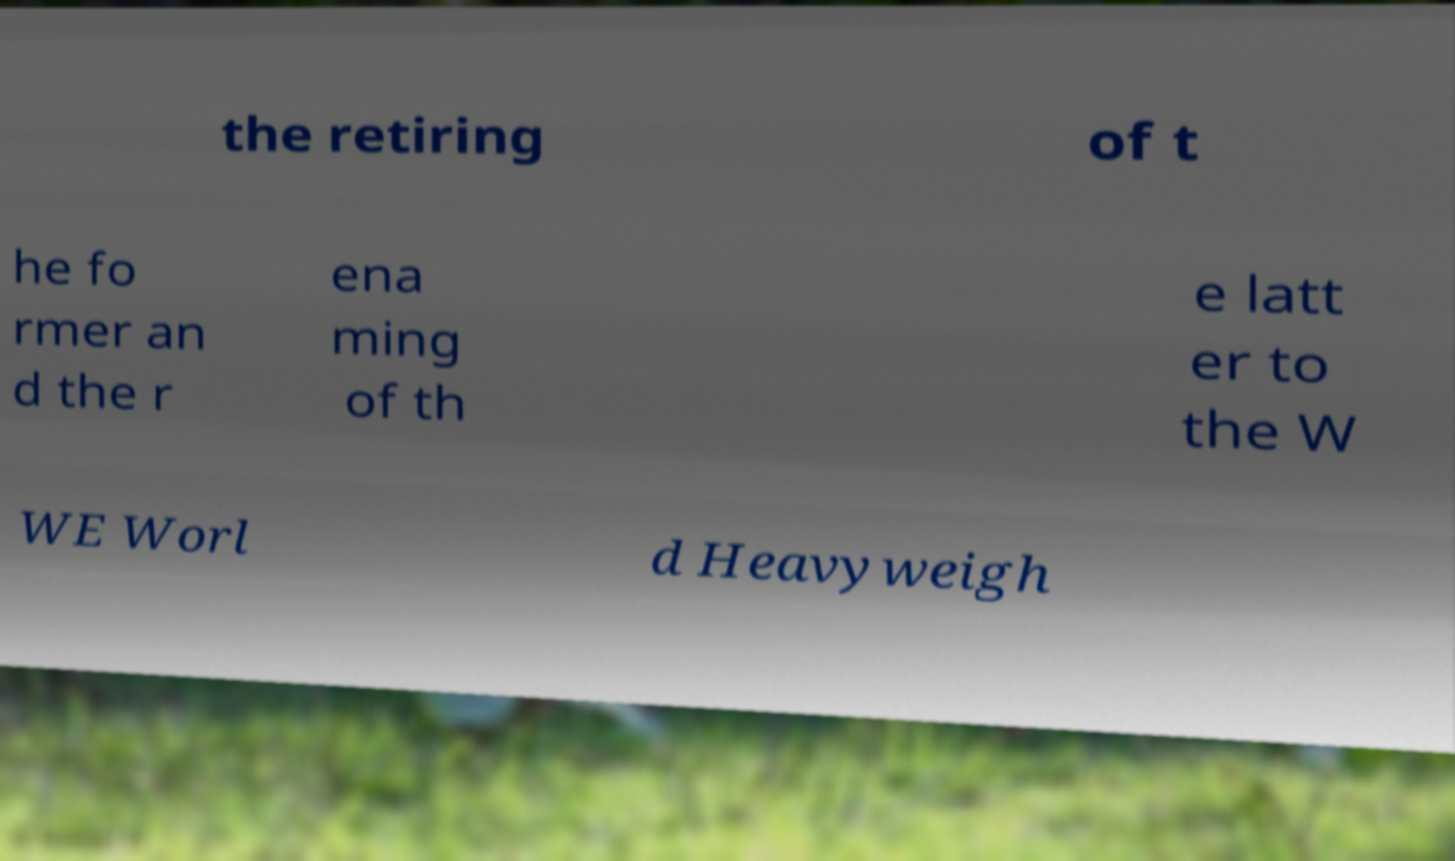What messages or text are displayed in this image? I need them in a readable, typed format. the retiring of t he fo rmer an d the r ena ming of th e latt er to the W WE Worl d Heavyweigh 